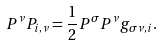Convert formula to latex. <formula><loc_0><loc_0><loc_500><loc_500>P ^ { \nu } P _ { i , \nu } = \frac { 1 } { 2 } P ^ { \sigma } P ^ { \nu } g _ { \sigma \nu , i } .</formula> 